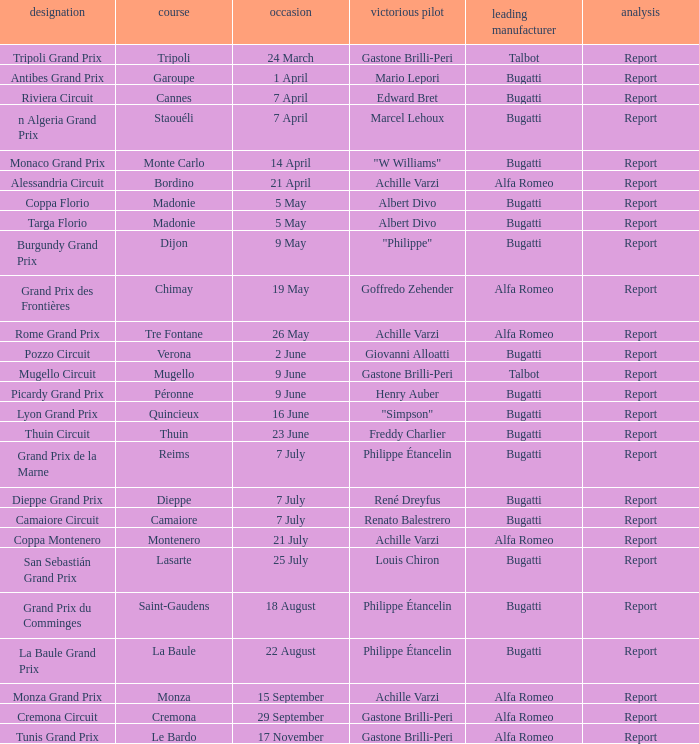What Winning driver has a Winning constructor of talbot? Gastone Brilli-Peri, Gastone Brilli-Peri. 